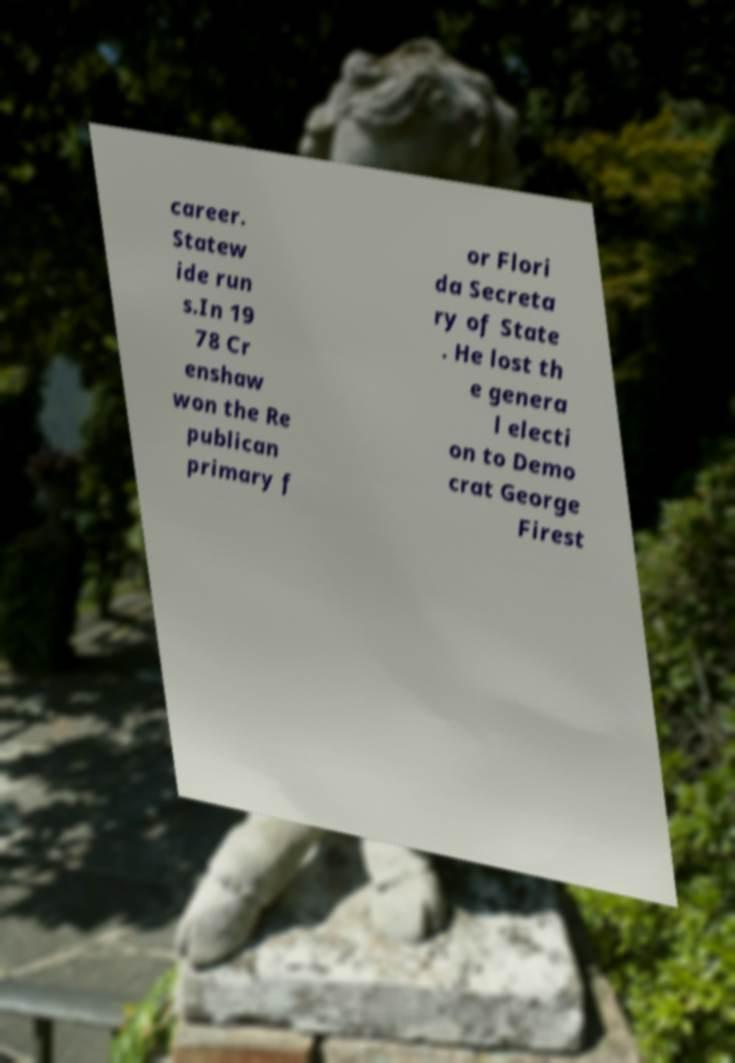Can you accurately transcribe the text from the provided image for me? career. Statew ide run s.In 19 78 Cr enshaw won the Re publican primary f or Flori da Secreta ry of State . He lost th e genera l electi on to Demo crat George Firest 